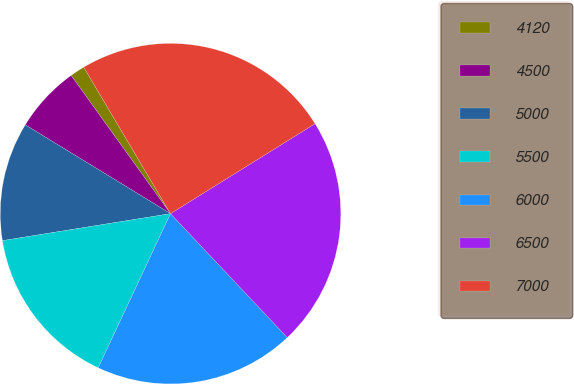Convert chart to OTSL. <chart><loc_0><loc_0><loc_500><loc_500><pie_chart><fcel>4120<fcel>4500<fcel>5000<fcel>5500<fcel>6000<fcel>6500<fcel>7000<nl><fcel>1.41%<fcel>6.34%<fcel>11.27%<fcel>15.49%<fcel>19.01%<fcel>21.83%<fcel>24.65%<nl></chart> 